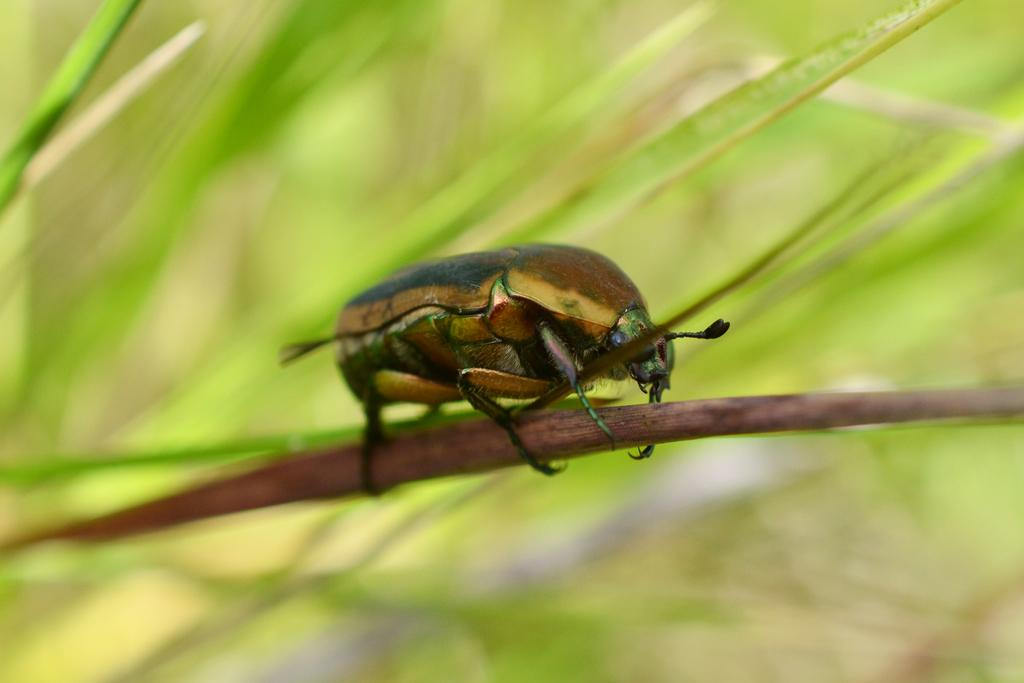What is located on the stem in the image? There is an insect on a stem in the image. How would you describe the appearance of the background in the image? The background of the image is blurred. What color is the background of the image? The background of the image is green in color. What type of mind control device can be seen in the image? There is no mind control device present in the image; it features an insect on a stem with a blurred green background. 